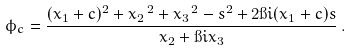<formula> <loc_0><loc_0><loc_500><loc_500>\phi _ { c } = \frac { ( x _ { 1 } + c ) ^ { 2 } + { x _ { 2 } } ^ { \, 2 } + { x _ { 3 } } ^ { \, 2 } - s ^ { 2 } + 2 \i i ( x _ { 1 } + c ) s } { x _ { 2 } + \i i x _ { 3 } } \, .</formula> 